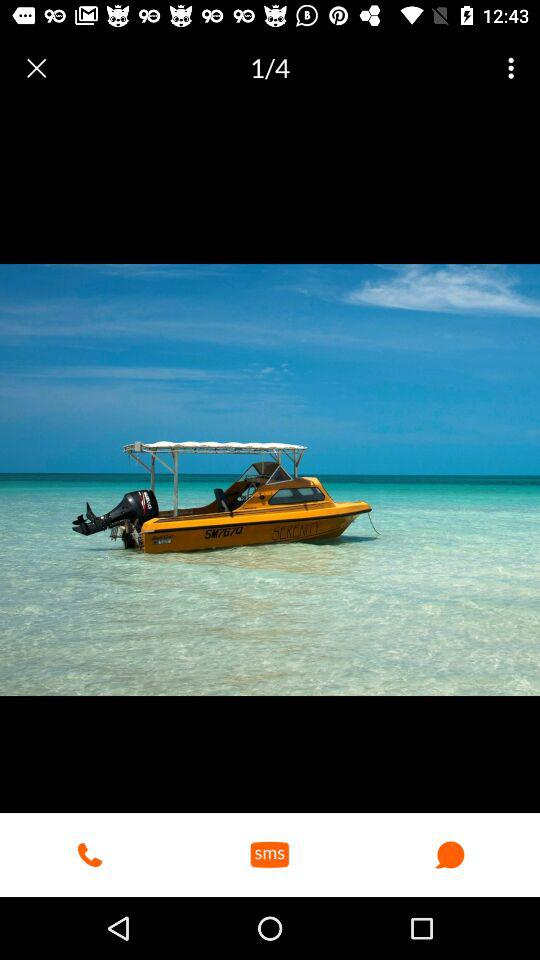At which image am I? You are at the first image. 